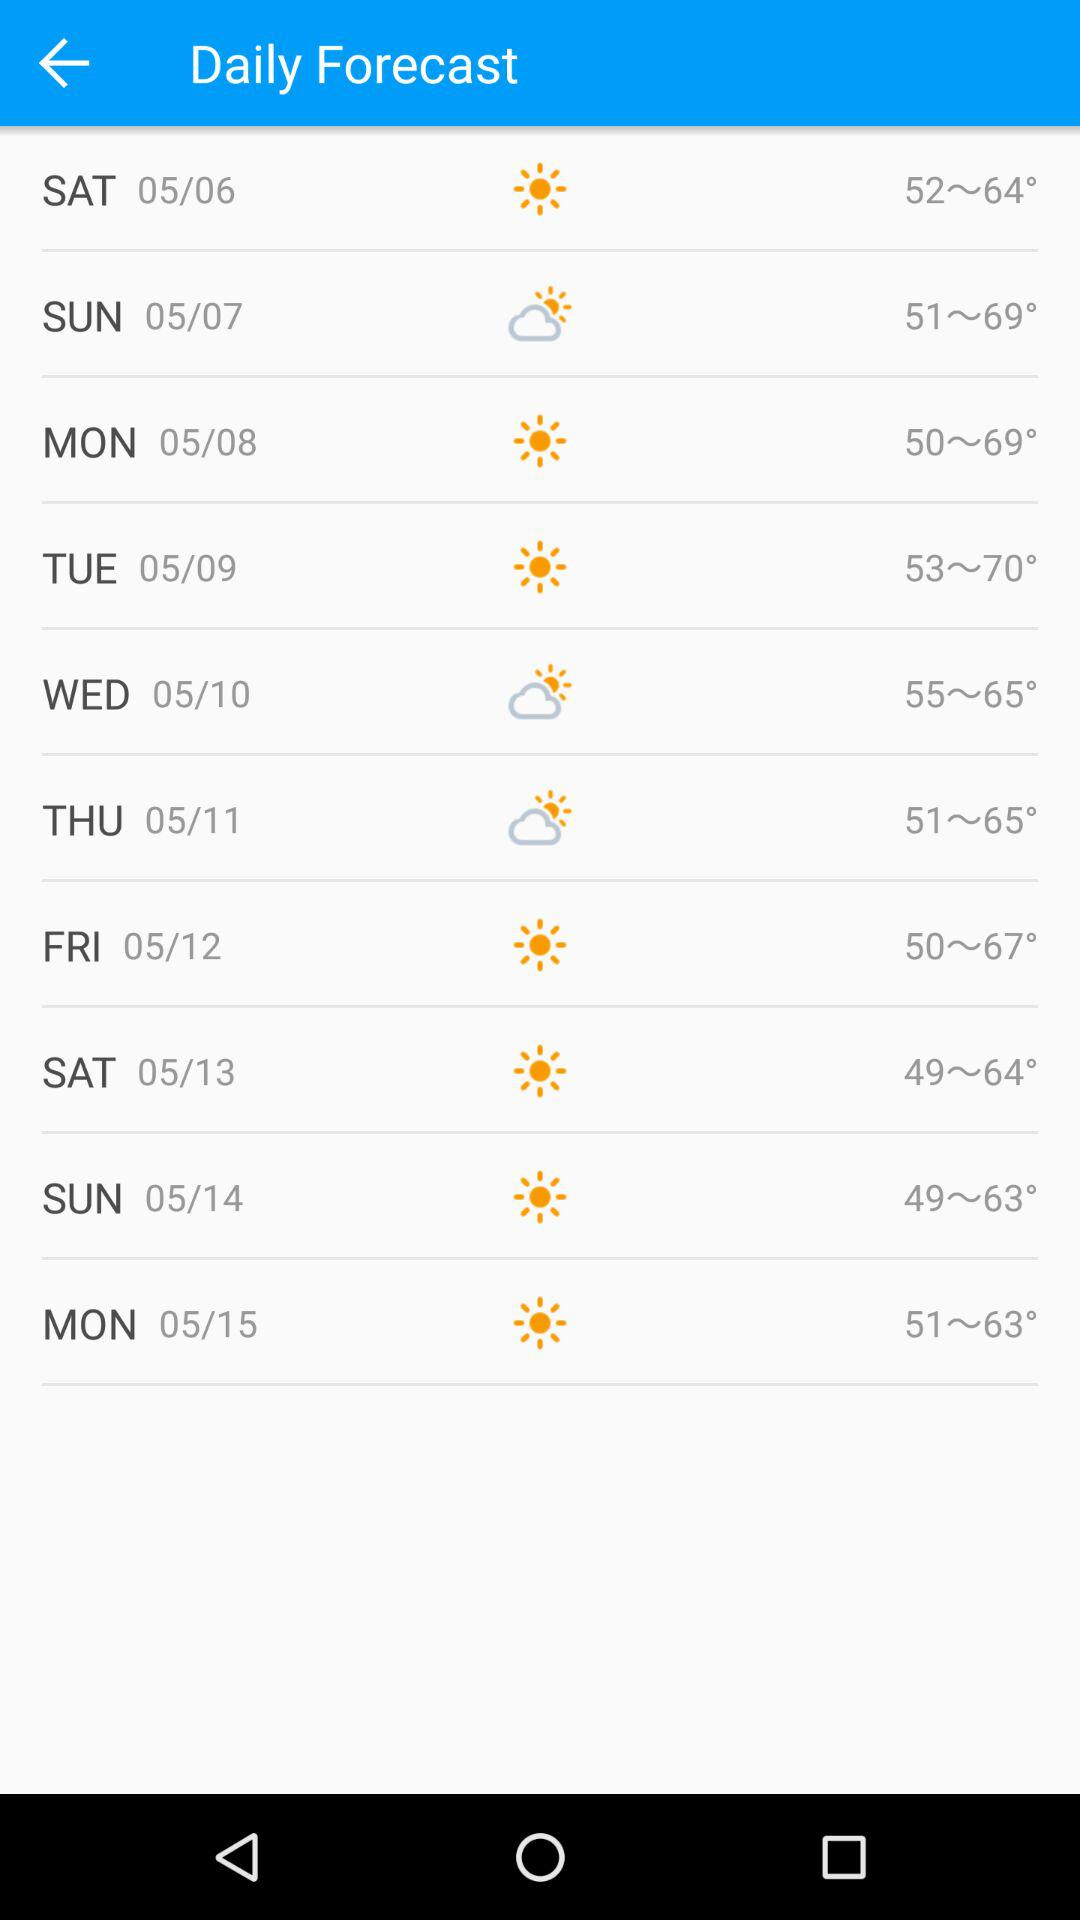How many days are there in the forecast?
Answer the question using a single word or phrase. 10 